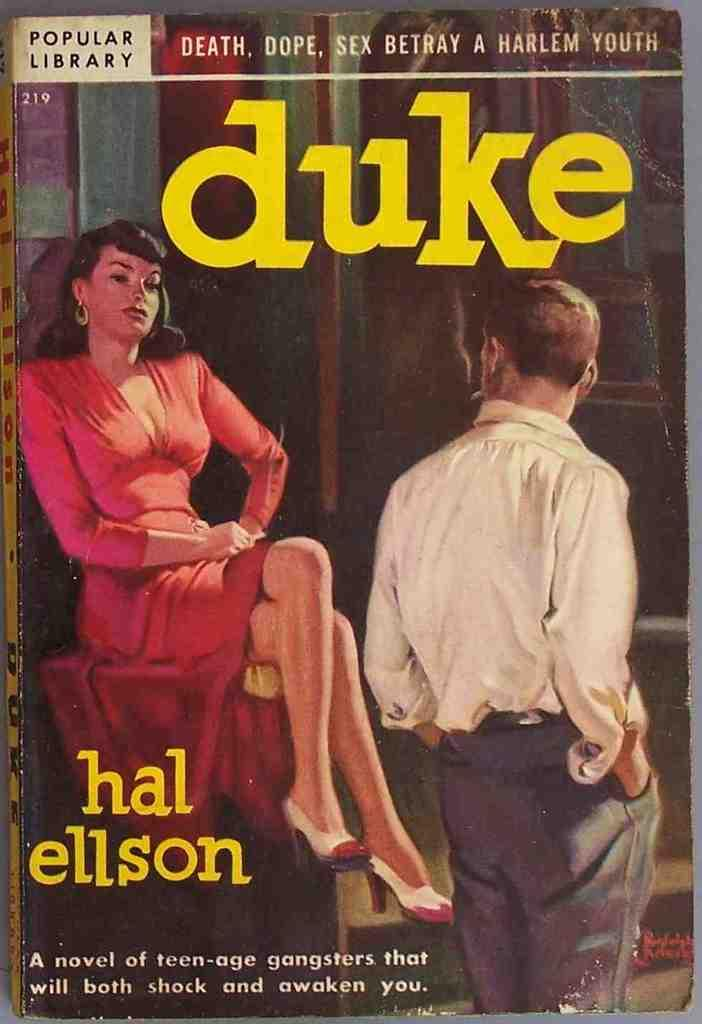Provide a one-sentence caption for the provided image. A book titled Duke by the author Hal Ellson. 